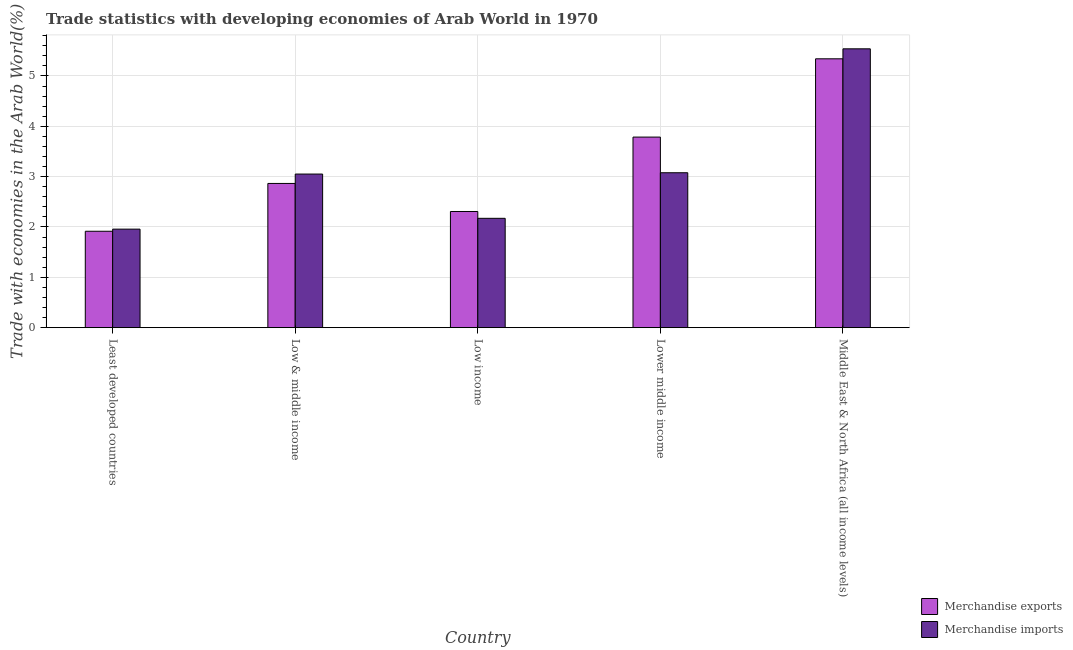How many groups of bars are there?
Ensure brevity in your answer.  5. Are the number of bars per tick equal to the number of legend labels?
Provide a succinct answer. Yes. How many bars are there on the 5th tick from the left?
Make the answer very short. 2. How many bars are there on the 2nd tick from the right?
Offer a terse response. 2. What is the label of the 5th group of bars from the left?
Provide a short and direct response. Middle East & North Africa (all income levels). In how many cases, is the number of bars for a given country not equal to the number of legend labels?
Provide a succinct answer. 0. What is the merchandise exports in Low income?
Your answer should be very brief. 2.31. Across all countries, what is the maximum merchandise exports?
Offer a terse response. 5.34. Across all countries, what is the minimum merchandise exports?
Your answer should be compact. 1.91. In which country was the merchandise imports maximum?
Your answer should be very brief. Middle East & North Africa (all income levels). In which country was the merchandise exports minimum?
Your answer should be compact. Least developed countries. What is the total merchandise exports in the graph?
Offer a terse response. 16.21. What is the difference between the merchandise exports in Low & middle income and that in Middle East & North Africa (all income levels)?
Your answer should be compact. -2.48. What is the difference between the merchandise exports in Low income and the merchandise imports in Least developed countries?
Offer a very short reply. 0.35. What is the average merchandise exports per country?
Keep it short and to the point. 3.24. What is the difference between the merchandise imports and merchandise exports in Least developed countries?
Provide a short and direct response. 0.04. In how many countries, is the merchandise imports greater than 5 %?
Your answer should be compact. 1. What is the ratio of the merchandise exports in Least developed countries to that in Lower middle income?
Your answer should be very brief. 0.51. Is the merchandise imports in Low income less than that in Middle East & North Africa (all income levels)?
Make the answer very short. Yes. Is the difference between the merchandise imports in Least developed countries and Middle East & North Africa (all income levels) greater than the difference between the merchandise exports in Least developed countries and Middle East & North Africa (all income levels)?
Your answer should be very brief. No. What is the difference between the highest and the second highest merchandise exports?
Offer a very short reply. 1.55. What is the difference between the highest and the lowest merchandise imports?
Offer a terse response. 3.58. In how many countries, is the merchandise imports greater than the average merchandise imports taken over all countries?
Your answer should be compact. 1. Is the sum of the merchandise imports in Least developed countries and Low & middle income greater than the maximum merchandise exports across all countries?
Offer a terse response. No. What does the 1st bar from the left in Least developed countries represents?
Make the answer very short. Merchandise exports. What does the 1st bar from the right in Least developed countries represents?
Offer a terse response. Merchandise imports. Are all the bars in the graph horizontal?
Give a very brief answer. No. How many countries are there in the graph?
Your response must be concise. 5. What is the difference between two consecutive major ticks on the Y-axis?
Give a very brief answer. 1. Are the values on the major ticks of Y-axis written in scientific E-notation?
Give a very brief answer. No. Does the graph contain any zero values?
Offer a very short reply. No. What is the title of the graph?
Your response must be concise. Trade statistics with developing economies of Arab World in 1970. Does "Domestic liabilities" appear as one of the legend labels in the graph?
Offer a terse response. No. What is the label or title of the Y-axis?
Offer a terse response. Trade with economies in the Arab World(%). What is the Trade with economies in the Arab World(%) in Merchandise exports in Least developed countries?
Your answer should be very brief. 1.91. What is the Trade with economies in the Arab World(%) in Merchandise imports in Least developed countries?
Provide a succinct answer. 1.96. What is the Trade with economies in the Arab World(%) in Merchandise exports in Low & middle income?
Give a very brief answer. 2.86. What is the Trade with economies in the Arab World(%) of Merchandise imports in Low & middle income?
Your response must be concise. 3.05. What is the Trade with economies in the Arab World(%) of Merchandise exports in Low income?
Keep it short and to the point. 2.31. What is the Trade with economies in the Arab World(%) in Merchandise imports in Low income?
Keep it short and to the point. 2.17. What is the Trade with economies in the Arab World(%) of Merchandise exports in Lower middle income?
Give a very brief answer. 3.79. What is the Trade with economies in the Arab World(%) in Merchandise imports in Lower middle income?
Keep it short and to the point. 3.08. What is the Trade with economies in the Arab World(%) in Merchandise exports in Middle East & North Africa (all income levels)?
Give a very brief answer. 5.34. What is the Trade with economies in the Arab World(%) in Merchandise imports in Middle East & North Africa (all income levels)?
Provide a short and direct response. 5.54. Across all countries, what is the maximum Trade with economies in the Arab World(%) in Merchandise exports?
Your response must be concise. 5.34. Across all countries, what is the maximum Trade with economies in the Arab World(%) in Merchandise imports?
Your answer should be very brief. 5.54. Across all countries, what is the minimum Trade with economies in the Arab World(%) in Merchandise exports?
Your answer should be very brief. 1.91. Across all countries, what is the minimum Trade with economies in the Arab World(%) in Merchandise imports?
Ensure brevity in your answer.  1.96. What is the total Trade with economies in the Arab World(%) of Merchandise exports in the graph?
Your answer should be compact. 16.21. What is the total Trade with economies in the Arab World(%) in Merchandise imports in the graph?
Ensure brevity in your answer.  15.8. What is the difference between the Trade with economies in the Arab World(%) in Merchandise exports in Least developed countries and that in Low & middle income?
Give a very brief answer. -0.95. What is the difference between the Trade with economies in the Arab World(%) in Merchandise imports in Least developed countries and that in Low & middle income?
Your answer should be compact. -1.09. What is the difference between the Trade with economies in the Arab World(%) in Merchandise exports in Least developed countries and that in Low income?
Your response must be concise. -0.39. What is the difference between the Trade with economies in the Arab World(%) in Merchandise imports in Least developed countries and that in Low income?
Your response must be concise. -0.21. What is the difference between the Trade with economies in the Arab World(%) of Merchandise exports in Least developed countries and that in Lower middle income?
Provide a succinct answer. -1.87. What is the difference between the Trade with economies in the Arab World(%) in Merchandise imports in Least developed countries and that in Lower middle income?
Make the answer very short. -1.12. What is the difference between the Trade with economies in the Arab World(%) of Merchandise exports in Least developed countries and that in Middle East & North Africa (all income levels)?
Offer a terse response. -3.43. What is the difference between the Trade with economies in the Arab World(%) of Merchandise imports in Least developed countries and that in Middle East & North Africa (all income levels)?
Your answer should be very brief. -3.58. What is the difference between the Trade with economies in the Arab World(%) of Merchandise exports in Low & middle income and that in Low income?
Offer a very short reply. 0.56. What is the difference between the Trade with economies in the Arab World(%) of Merchandise imports in Low & middle income and that in Low income?
Your answer should be very brief. 0.88. What is the difference between the Trade with economies in the Arab World(%) of Merchandise exports in Low & middle income and that in Lower middle income?
Your response must be concise. -0.92. What is the difference between the Trade with economies in the Arab World(%) in Merchandise imports in Low & middle income and that in Lower middle income?
Keep it short and to the point. -0.03. What is the difference between the Trade with economies in the Arab World(%) in Merchandise exports in Low & middle income and that in Middle East & North Africa (all income levels)?
Your answer should be very brief. -2.48. What is the difference between the Trade with economies in the Arab World(%) of Merchandise imports in Low & middle income and that in Middle East & North Africa (all income levels)?
Keep it short and to the point. -2.49. What is the difference between the Trade with economies in the Arab World(%) of Merchandise exports in Low income and that in Lower middle income?
Your answer should be compact. -1.48. What is the difference between the Trade with economies in the Arab World(%) in Merchandise imports in Low income and that in Lower middle income?
Your answer should be compact. -0.91. What is the difference between the Trade with economies in the Arab World(%) of Merchandise exports in Low income and that in Middle East & North Africa (all income levels)?
Offer a very short reply. -3.03. What is the difference between the Trade with economies in the Arab World(%) of Merchandise imports in Low income and that in Middle East & North Africa (all income levels)?
Your response must be concise. -3.37. What is the difference between the Trade with economies in the Arab World(%) of Merchandise exports in Lower middle income and that in Middle East & North Africa (all income levels)?
Make the answer very short. -1.55. What is the difference between the Trade with economies in the Arab World(%) in Merchandise imports in Lower middle income and that in Middle East & North Africa (all income levels)?
Your response must be concise. -2.46. What is the difference between the Trade with economies in the Arab World(%) of Merchandise exports in Least developed countries and the Trade with economies in the Arab World(%) of Merchandise imports in Low & middle income?
Your answer should be very brief. -1.14. What is the difference between the Trade with economies in the Arab World(%) in Merchandise exports in Least developed countries and the Trade with economies in the Arab World(%) in Merchandise imports in Low income?
Ensure brevity in your answer.  -0.26. What is the difference between the Trade with economies in the Arab World(%) of Merchandise exports in Least developed countries and the Trade with economies in the Arab World(%) of Merchandise imports in Lower middle income?
Your answer should be compact. -1.16. What is the difference between the Trade with economies in the Arab World(%) in Merchandise exports in Least developed countries and the Trade with economies in the Arab World(%) in Merchandise imports in Middle East & North Africa (all income levels)?
Provide a short and direct response. -3.62. What is the difference between the Trade with economies in the Arab World(%) of Merchandise exports in Low & middle income and the Trade with economies in the Arab World(%) of Merchandise imports in Low income?
Provide a short and direct response. 0.69. What is the difference between the Trade with economies in the Arab World(%) of Merchandise exports in Low & middle income and the Trade with economies in the Arab World(%) of Merchandise imports in Lower middle income?
Make the answer very short. -0.21. What is the difference between the Trade with economies in the Arab World(%) in Merchandise exports in Low & middle income and the Trade with economies in the Arab World(%) in Merchandise imports in Middle East & North Africa (all income levels)?
Your answer should be very brief. -2.67. What is the difference between the Trade with economies in the Arab World(%) in Merchandise exports in Low income and the Trade with economies in the Arab World(%) in Merchandise imports in Lower middle income?
Your response must be concise. -0.77. What is the difference between the Trade with economies in the Arab World(%) in Merchandise exports in Low income and the Trade with economies in the Arab World(%) in Merchandise imports in Middle East & North Africa (all income levels)?
Make the answer very short. -3.23. What is the difference between the Trade with economies in the Arab World(%) of Merchandise exports in Lower middle income and the Trade with economies in the Arab World(%) of Merchandise imports in Middle East & North Africa (all income levels)?
Provide a succinct answer. -1.75. What is the average Trade with economies in the Arab World(%) in Merchandise exports per country?
Ensure brevity in your answer.  3.24. What is the average Trade with economies in the Arab World(%) of Merchandise imports per country?
Your answer should be very brief. 3.16. What is the difference between the Trade with economies in the Arab World(%) of Merchandise exports and Trade with economies in the Arab World(%) of Merchandise imports in Least developed countries?
Give a very brief answer. -0.04. What is the difference between the Trade with economies in the Arab World(%) of Merchandise exports and Trade with economies in the Arab World(%) of Merchandise imports in Low & middle income?
Keep it short and to the point. -0.19. What is the difference between the Trade with economies in the Arab World(%) of Merchandise exports and Trade with economies in the Arab World(%) of Merchandise imports in Low income?
Offer a very short reply. 0.14. What is the difference between the Trade with economies in the Arab World(%) of Merchandise exports and Trade with economies in the Arab World(%) of Merchandise imports in Lower middle income?
Make the answer very short. 0.71. What is the difference between the Trade with economies in the Arab World(%) of Merchandise exports and Trade with economies in the Arab World(%) of Merchandise imports in Middle East & North Africa (all income levels)?
Give a very brief answer. -0.2. What is the ratio of the Trade with economies in the Arab World(%) of Merchandise exports in Least developed countries to that in Low & middle income?
Provide a short and direct response. 0.67. What is the ratio of the Trade with economies in the Arab World(%) of Merchandise imports in Least developed countries to that in Low & middle income?
Ensure brevity in your answer.  0.64. What is the ratio of the Trade with economies in the Arab World(%) of Merchandise exports in Least developed countries to that in Low income?
Offer a terse response. 0.83. What is the ratio of the Trade with economies in the Arab World(%) in Merchandise imports in Least developed countries to that in Low income?
Your response must be concise. 0.9. What is the ratio of the Trade with economies in the Arab World(%) in Merchandise exports in Least developed countries to that in Lower middle income?
Offer a terse response. 0.51. What is the ratio of the Trade with economies in the Arab World(%) in Merchandise imports in Least developed countries to that in Lower middle income?
Keep it short and to the point. 0.64. What is the ratio of the Trade with economies in the Arab World(%) of Merchandise exports in Least developed countries to that in Middle East & North Africa (all income levels)?
Make the answer very short. 0.36. What is the ratio of the Trade with economies in the Arab World(%) in Merchandise imports in Least developed countries to that in Middle East & North Africa (all income levels)?
Offer a terse response. 0.35. What is the ratio of the Trade with economies in the Arab World(%) in Merchandise exports in Low & middle income to that in Low income?
Offer a terse response. 1.24. What is the ratio of the Trade with economies in the Arab World(%) in Merchandise imports in Low & middle income to that in Low income?
Offer a very short reply. 1.4. What is the ratio of the Trade with economies in the Arab World(%) of Merchandise exports in Low & middle income to that in Lower middle income?
Keep it short and to the point. 0.76. What is the ratio of the Trade with economies in the Arab World(%) of Merchandise exports in Low & middle income to that in Middle East & North Africa (all income levels)?
Your response must be concise. 0.54. What is the ratio of the Trade with economies in the Arab World(%) in Merchandise imports in Low & middle income to that in Middle East & North Africa (all income levels)?
Give a very brief answer. 0.55. What is the ratio of the Trade with economies in the Arab World(%) in Merchandise exports in Low income to that in Lower middle income?
Offer a very short reply. 0.61. What is the ratio of the Trade with economies in the Arab World(%) in Merchandise imports in Low income to that in Lower middle income?
Keep it short and to the point. 0.71. What is the ratio of the Trade with economies in the Arab World(%) of Merchandise exports in Low income to that in Middle East & North Africa (all income levels)?
Keep it short and to the point. 0.43. What is the ratio of the Trade with economies in the Arab World(%) of Merchandise imports in Low income to that in Middle East & North Africa (all income levels)?
Provide a short and direct response. 0.39. What is the ratio of the Trade with economies in the Arab World(%) in Merchandise exports in Lower middle income to that in Middle East & North Africa (all income levels)?
Offer a very short reply. 0.71. What is the ratio of the Trade with economies in the Arab World(%) of Merchandise imports in Lower middle income to that in Middle East & North Africa (all income levels)?
Your answer should be very brief. 0.56. What is the difference between the highest and the second highest Trade with economies in the Arab World(%) of Merchandise exports?
Keep it short and to the point. 1.55. What is the difference between the highest and the second highest Trade with economies in the Arab World(%) in Merchandise imports?
Provide a short and direct response. 2.46. What is the difference between the highest and the lowest Trade with economies in the Arab World(%) in Merchandise exports?
Offer a terse response. 3.43. What is the difference between the highest and the lowest Trade with economies in the Arab World(%) in Merchandise imports?
Offer a terse response. 3.58. 